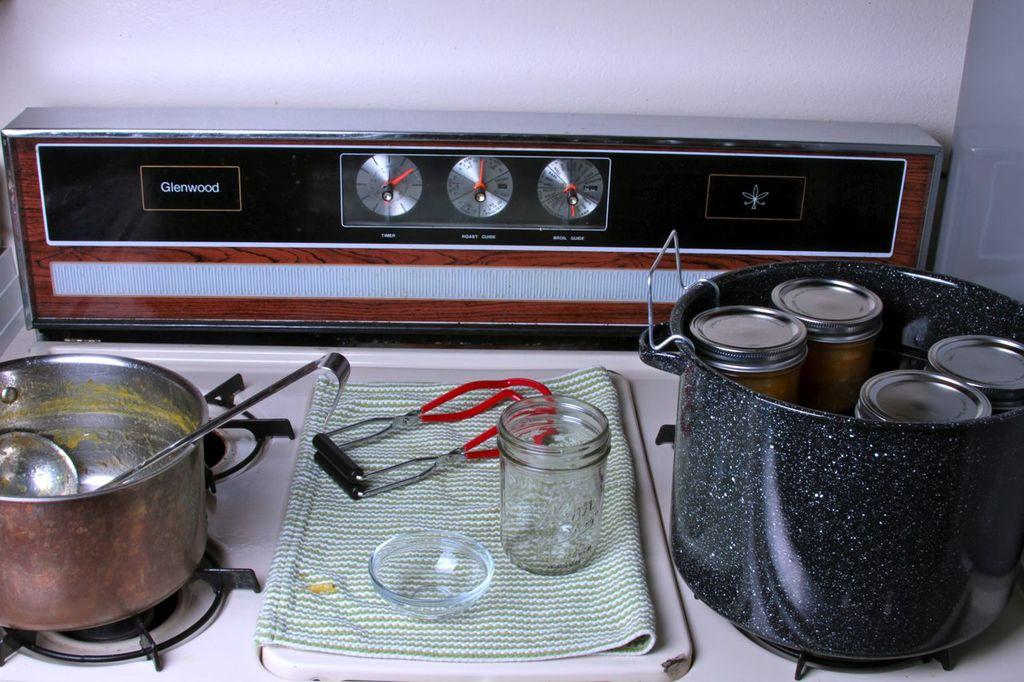<image>
Give a short and clear explanation of the subsequent image. a stove  that is the glenwood brand 